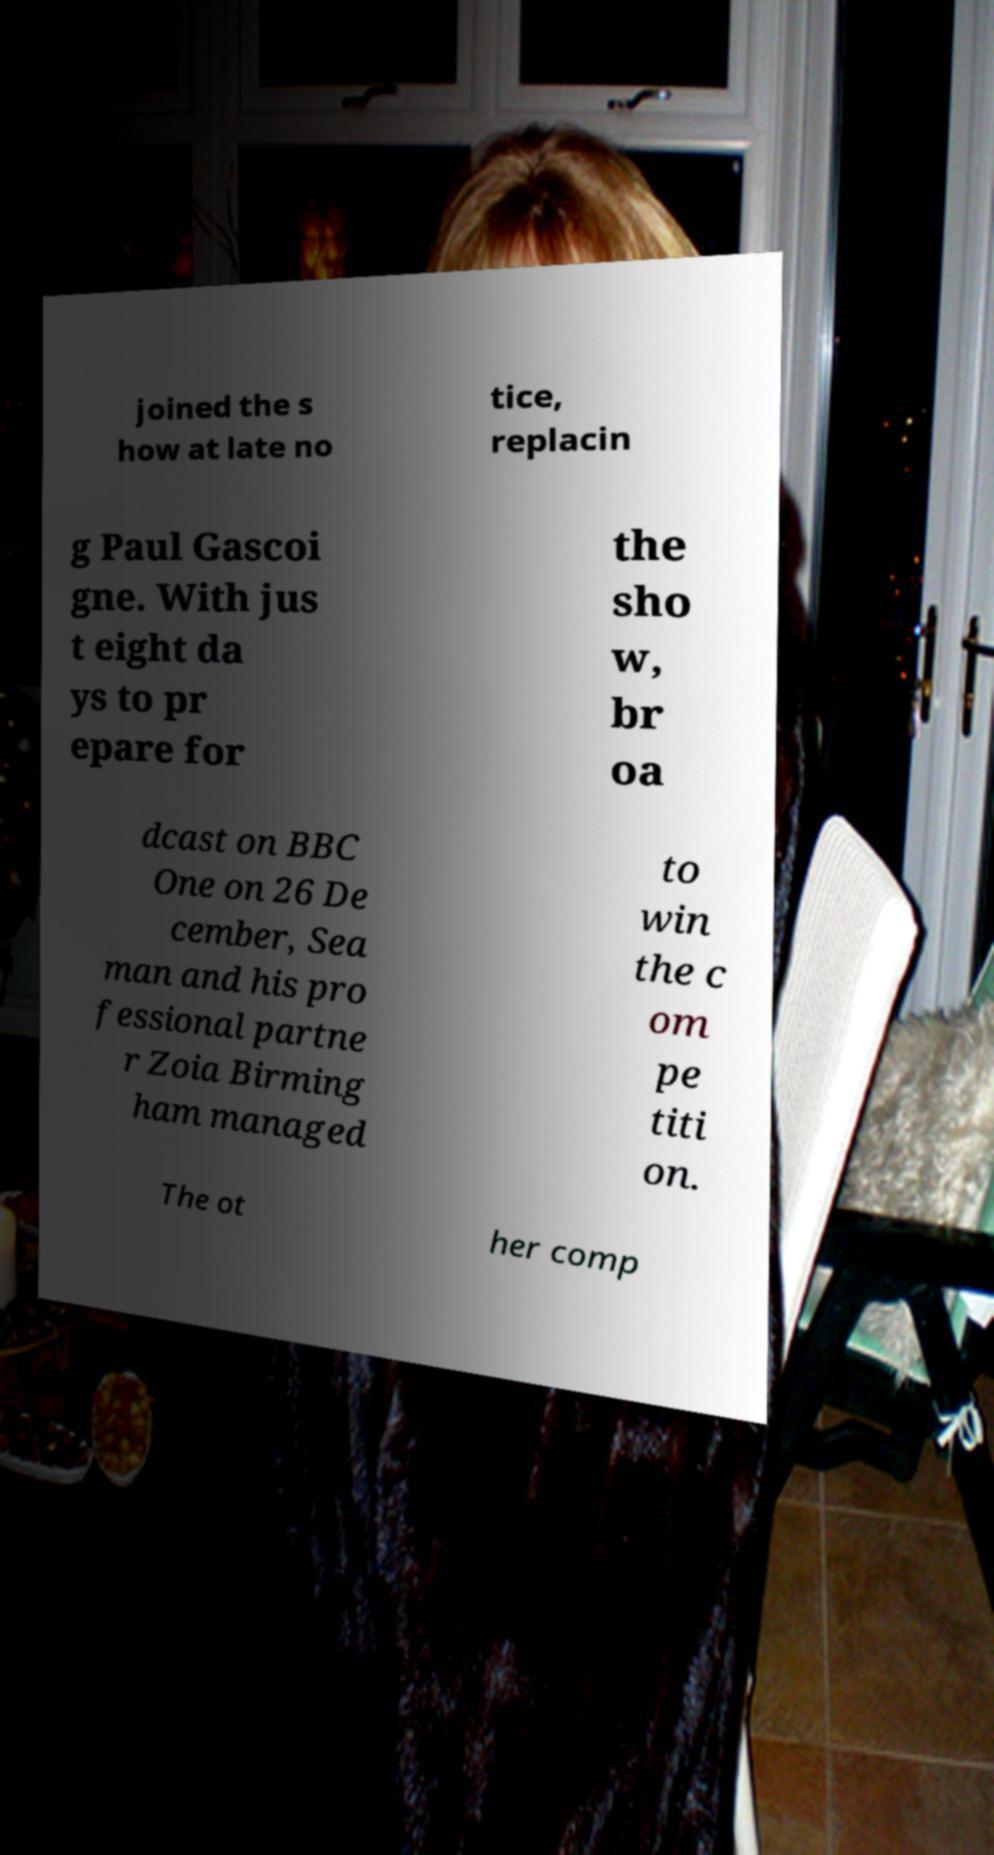Please identify and transcribe the text found in this image. joined the s how at late no tice, replacin g Paul Gascoi gne. With jus t eight da ys to pr epare for the sho w, br oa dcast on BBC One on 26 De cember, Sea man and his pro fessional partne r Zoia Birming ham managed to win the c om pe titi on. The ot her comp 